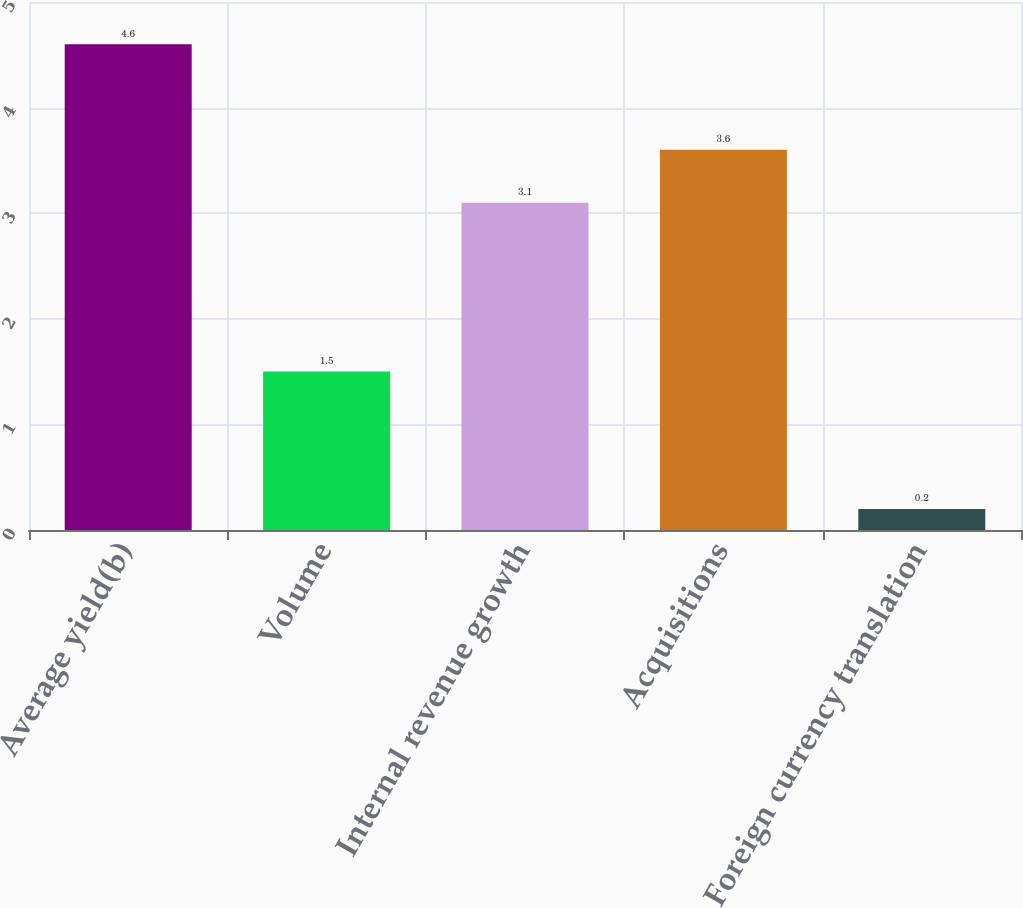<chart> <loc_0><loc_0><loc_500><loc_500><bar_chart><fcel>Average yield(b)<fcel>Volume<fcel>Internal revenue growth<fcel>Acquisitions<fcel>Foreign currency translation<nl><fcel>4.6<fcel>1.5<fcel>3.1<fcel>3.6<fcel>0.2<nl></chart> 